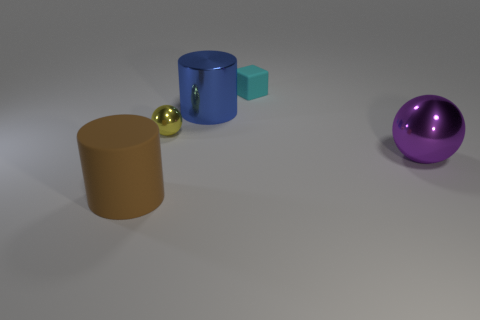you are given some question and answer pairs as context, and you will answer the question at the end based on the image.

What number of cylinders are either tiny cyan rubber objects or purple shiny things? 0
What color is the tiny thing to the right of the blue cylinder? cyan
What number of metallic things are tiny brown things or cyan things? 0
There is a ball to the right of the big cylinder behind the brown matte cylinder; what is it made of? metal
The large rubber thing has what color? brown
Is there a small metal object that is on the right side of the rubber thing in front of the tiny cyan object? yes
What is the material of the blue object? metal
Are there any other things that have the same color as the tiny matte thing? no

Is the material of the big cylinder to the left of the blue object the same as the ball to the left of the blue metal cylinder? The question asks if the material of the big cylinder to the left of the blue object is the same as the material of the ball to the left of the blue metal cylinder. Based on the provided context, we know the blue object is made of metal. Observing the scene, we can see that there is only one ball to the left of the blue cylinder, which is the purple sphere, and the previous answer states it is made of metal. The large cylinder, described as the "large rubber thing," is implied to have a different material—rubber. Therefore, the material of the big cylinder (rubber) is not the same as the ball (metal) to the left of the blue metal cylinder. 